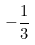<formula> <loc_0><loc_0><loc_500><loc_500>- \frac { 1 } { 3 }</formula> 